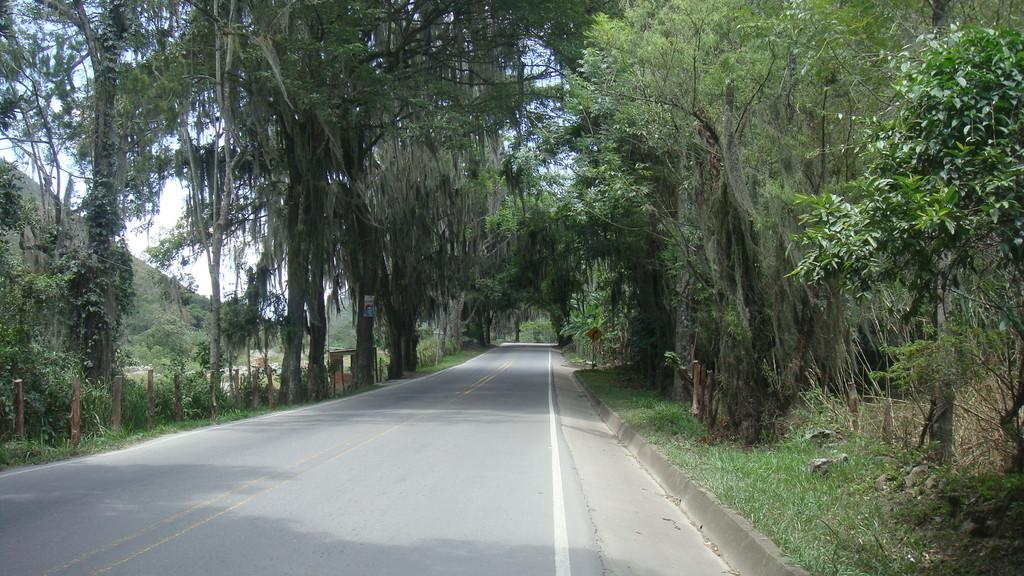What type of vegetation can be seen in the image? There are trees in the image. What is located between the trees? There is a road between the trees. What type of ground cover is present in the image? Grass is present in the image. What type of material is visible in the image? Stones are visible in the image. What geographical feature can be seen in the image? There is a hill in the image. What is the color of the sky in the image? The sky is white in the image. Can you see anyone attempting to wear a mask in the image? There is no one present in the image, and therefore no attempt to wear a mask can be observed. What type of dirt is visible on the hill in the image? There is no dirt visible on the hill in the image; it is covered with grass and trees. 